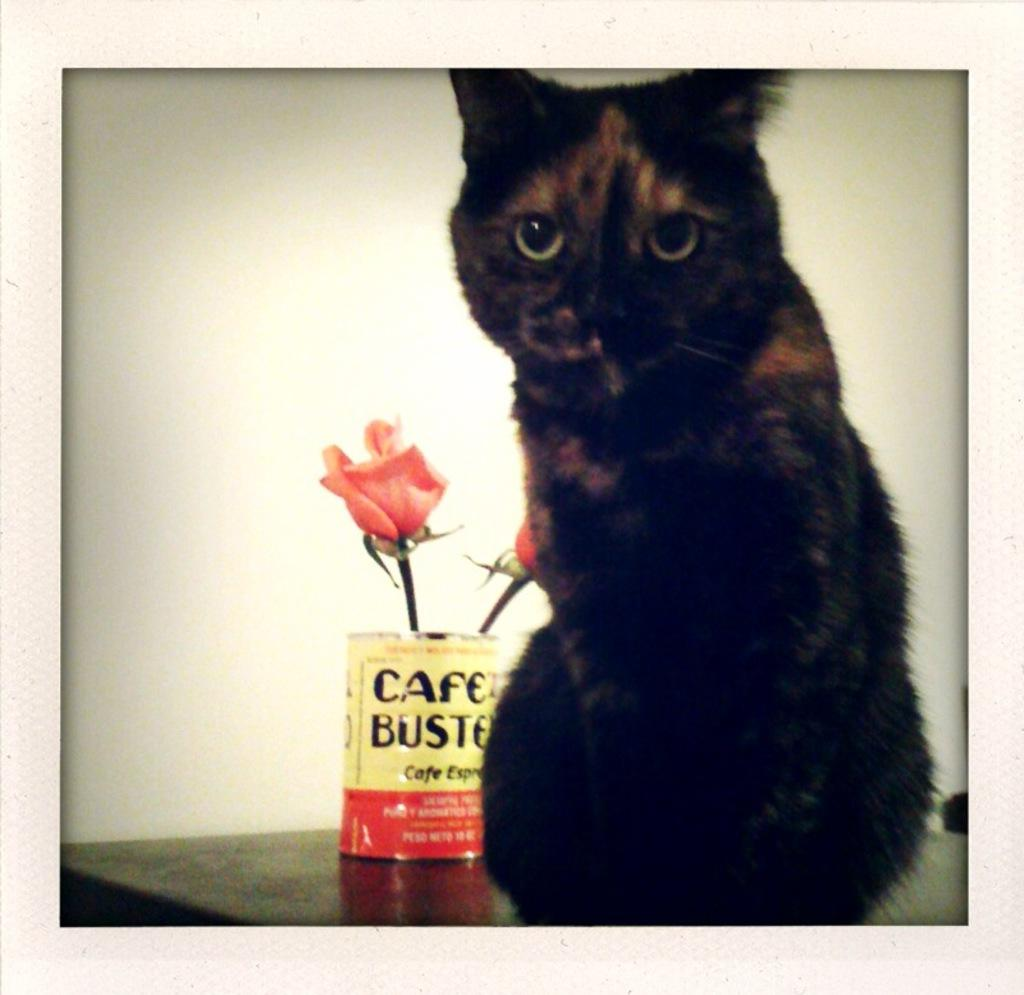What animal is on the table in the image? There is a cat on a table in the image. What type of decorative item is present in the image? There are flowers in a container in the image. Where is the container with flowers located in relation to the table? The container with flowers is placed beside the table. What type of quill is the cat using to write a letter in the image? There is no quill or letter-writing activity present in the image; the cat is simply sitting on the table. 